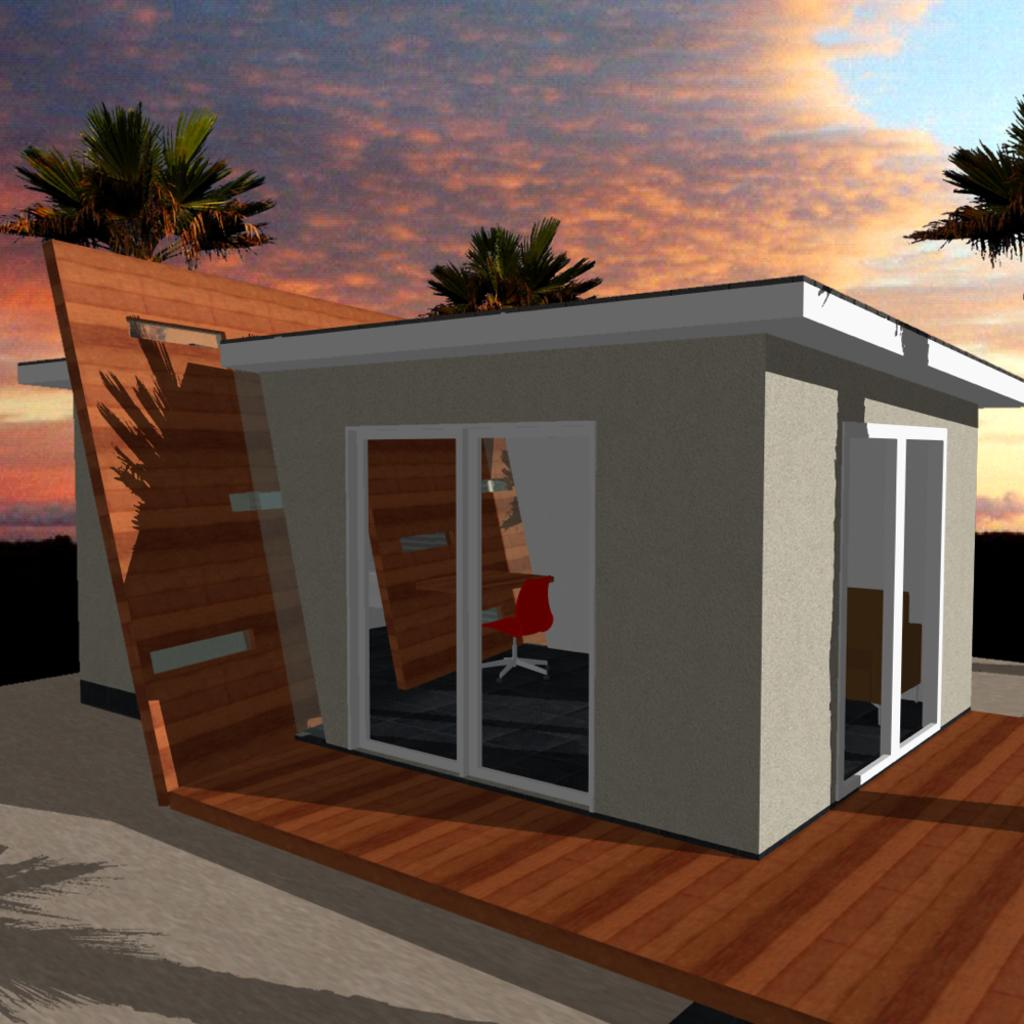What is the main subject of the picture? The main subject of the picture is a graphical image of a house. What other elements can be seen in the picture? There are trees visible in the picture. How would you describe the sky in the picture? The sky is blue and cloudy in the picture. What is the name of the person standing next to the house in the picture? There is no person standing next to the house in the picture. 